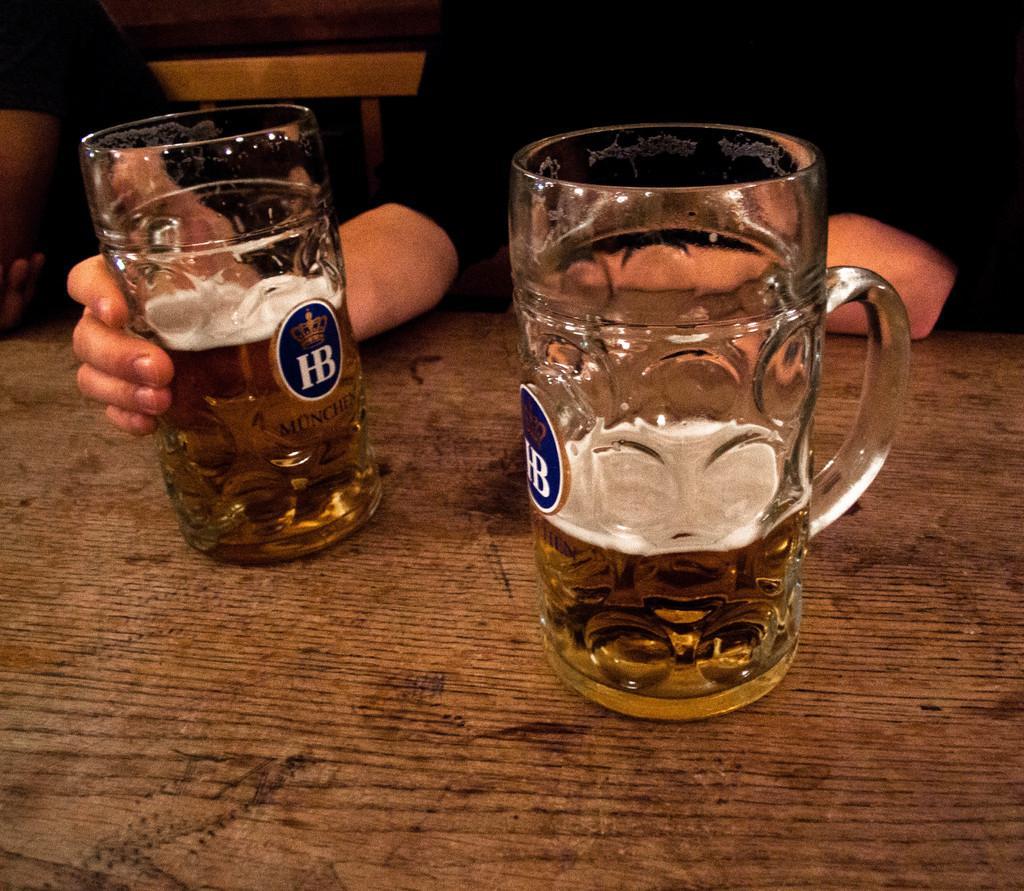Could you give a brief overview of what you see in this image? In this image right side there is a person with black shirt sitting on the bench and kept hands on the bench and holding a glass with drink. On the left side hand in the glass there is a text on that. There is a label with blue color letters h And b written on that. The label and Another glass right side kept on the table. There is a label with H and b with blue color attached to the glass. And there is a drink on the glass. And left top most person hand visible on the table. 